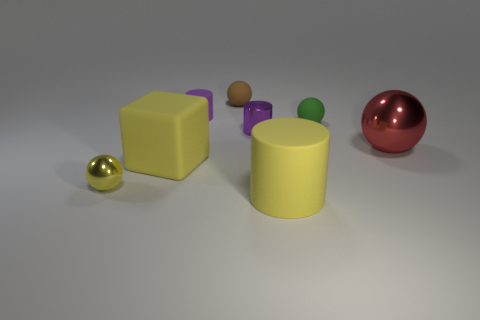Add 2 balls. How many objects exist? 10 Subtract all cylinders. How many objects are left? 5 Subtract all matte things. Subtract all red shiny spheres. How many objects are left? 2 Add 4 large shiny objects. How many large shiny objects are left? 5 Add 1 matte things. How many matte things exist? 6 Subtract 0 purple spheres. How many objects are left? 8 